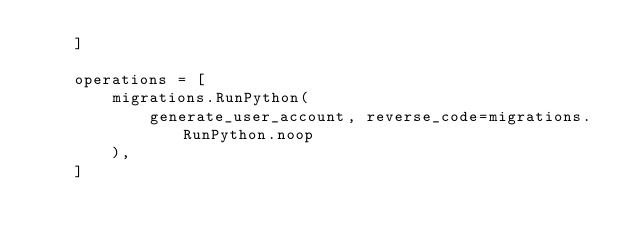<code> <loc_0><loc_0><loc_500><loc_500><_Python_>    ]

    operations = [
        migrations.RunPython(
            generate_user_account, reverse_code=migrations.RunPython.noop
        ),
    ]
</code> 